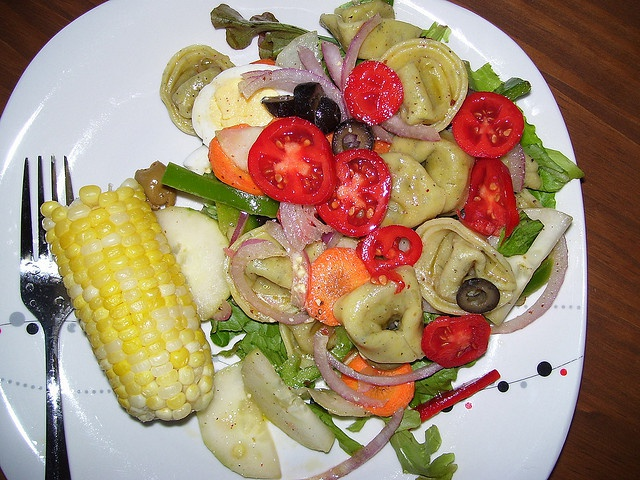Describe the objects in this image and their specific colors. I can see dining table in lightgray, maroon, tan, black, and olive tones, fork in black, white, gray, and darkgray tones, carrot in black, red, and salmon tones, carrot in black, red, salmon, brown, and darkgray tones, and carrot in black, red, orange, and salmon tones in this image. 